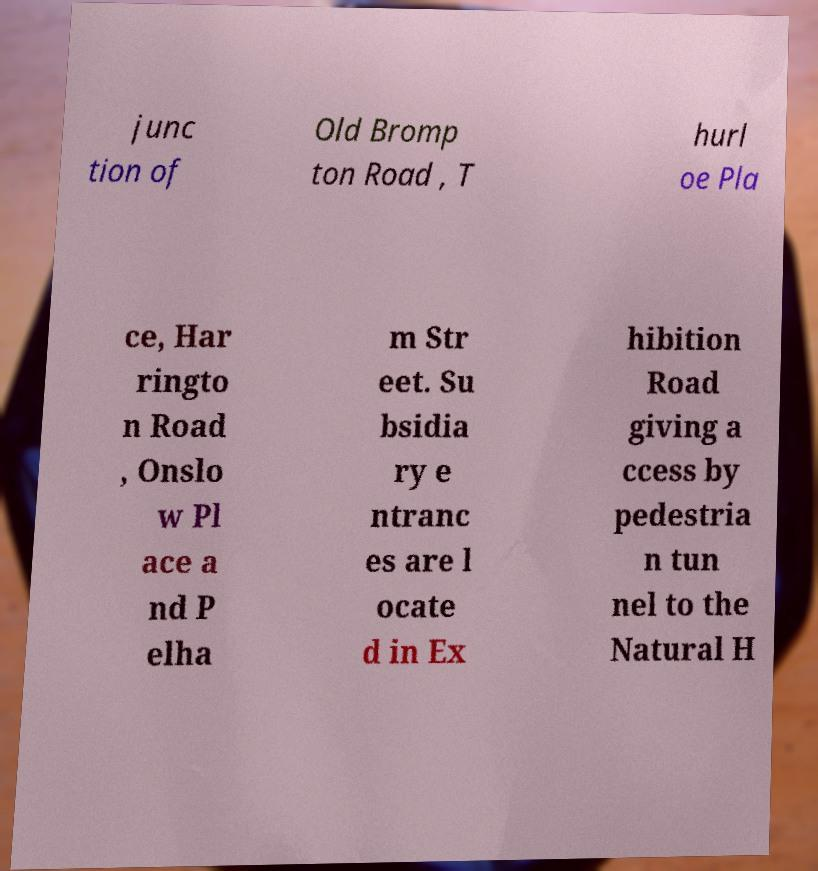What messages or text are displayed in this image? I need them in a readable, typed format. junc tion of Old Bromp ton Road , T hurl oe Pla ce, Har ringto n Road , Onslo w Pl ace a nd P elha m Str eet. Su bsidia ry e ntranc es are l ocate d in Ex hibition Road giving a ccess by pedestria n tun nel to the Natural H 